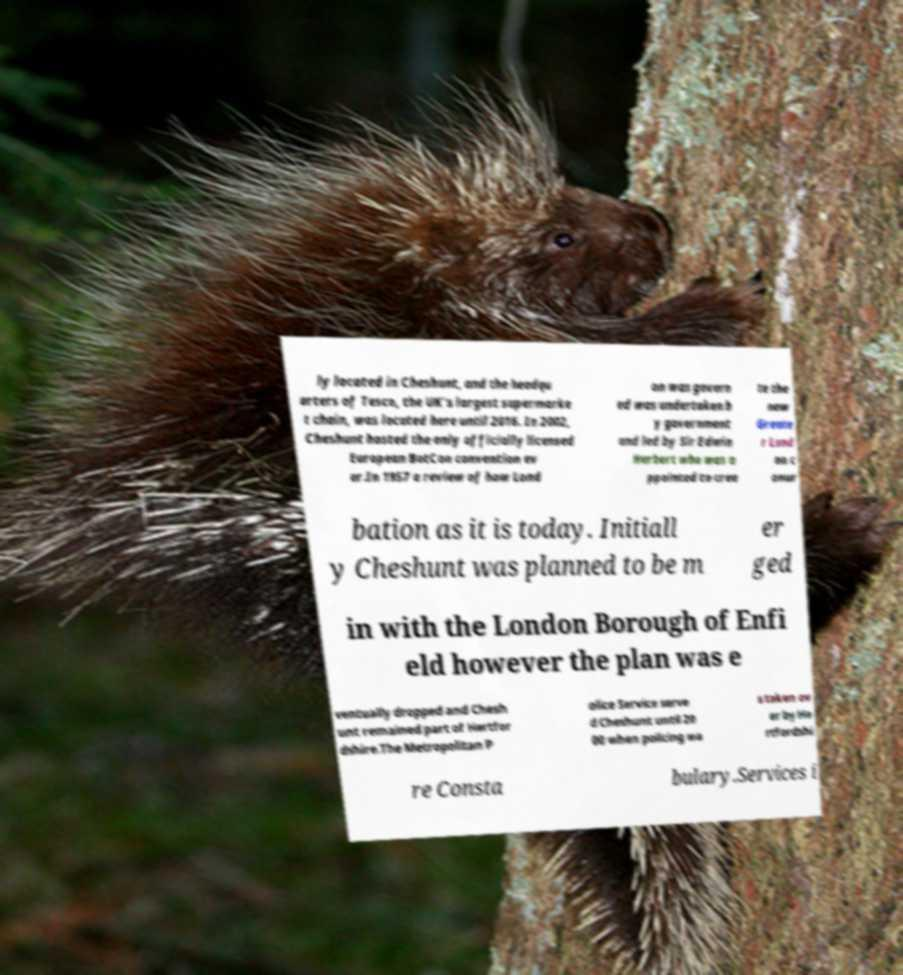Please read and relay the text visible in this image. What does it say? ly located in Cheshunt, and the headqu arters of Tesco, the UK's largest supermarke t chain, was located here until 2016. In 2002, Cheshunt hosted the only officially licensed European BotCon convention ev er.In 1957 a review of how Lond on was govern ed was undertaken b y government and led by Sir Edwin Herbert who was a ppointed to crea te the new Greate r Lond on c onur bation as it is today. Initiall y Cheshunt was planned to be m er ged in with the London Borough of Enfi eld however the plan was e ventually dropped and Chesh unt remained part of Hertfor dshire.The Metropolitan P olice Service serve d Cheshunt until 20 00 when policing wa s taken ov er by He rtfordshi re Consta bulary.Services i 